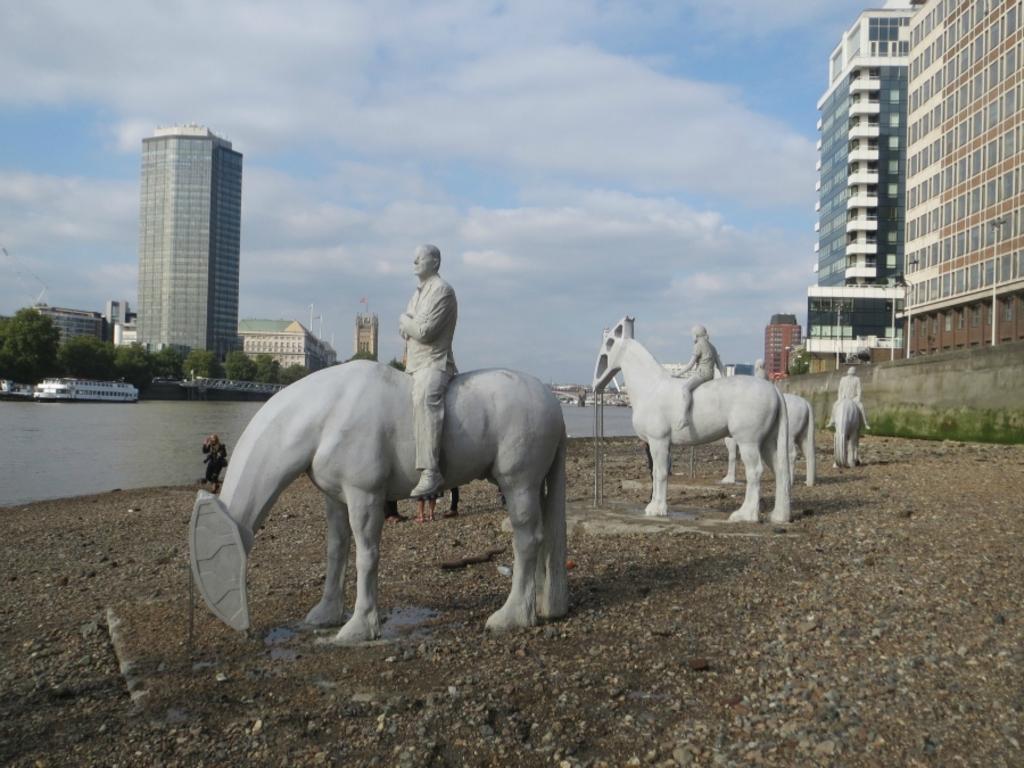Can you describe this image briefly? In this picture we can see statues in the front, at the bottom there are some stones, on the left side we can see water, there is a ship in the water, in the background there are some buildings and trees, we can see some people in the middle, there is the sky at the top of the picture. 